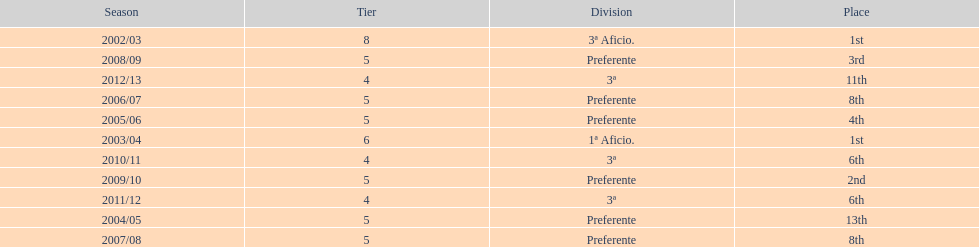What place was 1a aficio and 3a aficio? 1st. 